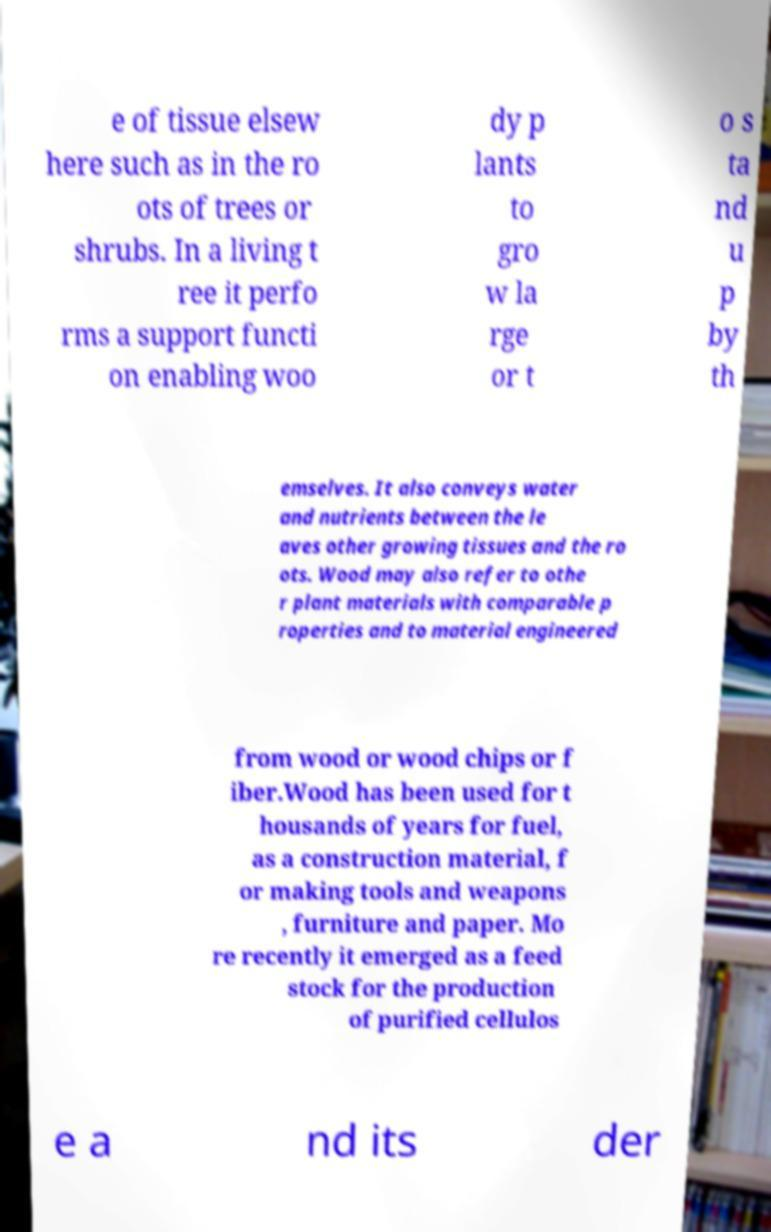Please read and relay the text visible in this image. What does it say? e of tissue elsew here such as in the ro ots of trees or shrubs. In a living t ree it perfo rms a support functi on enabling woo dy p lants to gro w la rge or t o s ta nd u p by th emselves. It also conveys water and nutrients between the le aves other growing tissues and the ro ots. Wood may also refer to othe r plant materials with comparable p roperties and to material engineered from wood or wood chips or f iber.Wood has been used for t housands of years for fuel, as a construction material, f or making tools and weapons , furniture and paper. Mo re recently it emerged as a feed stock for the production of purified cellulos e a nd its der 